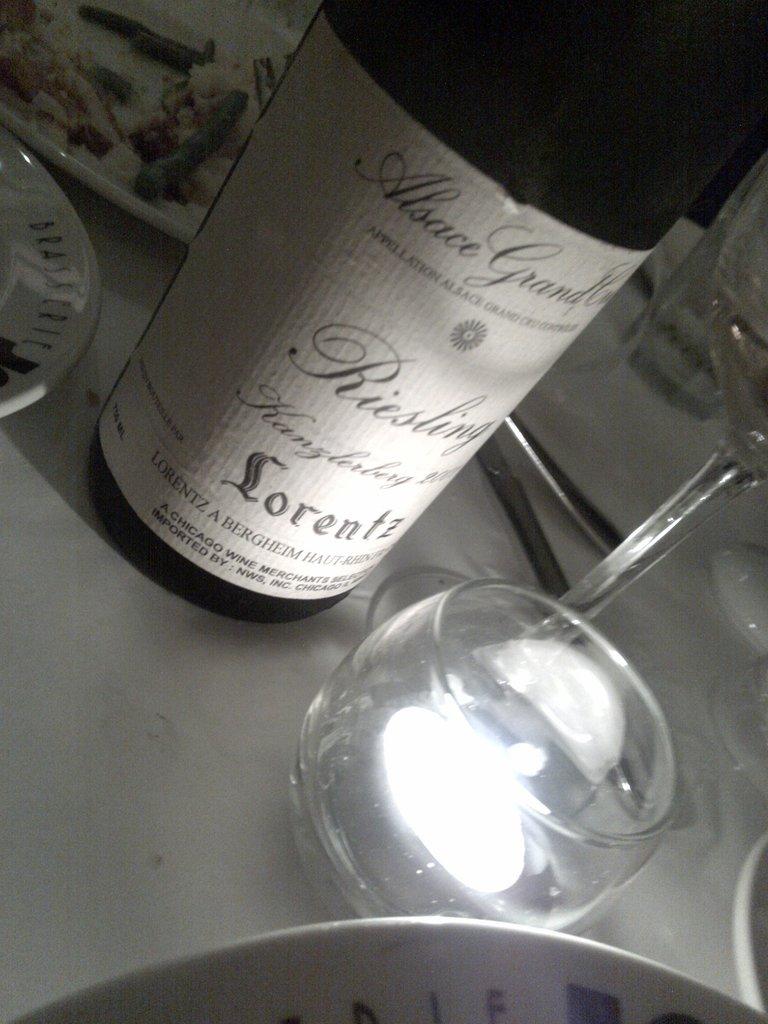From which city is this wine?
Make the answer very short. Chicago. 